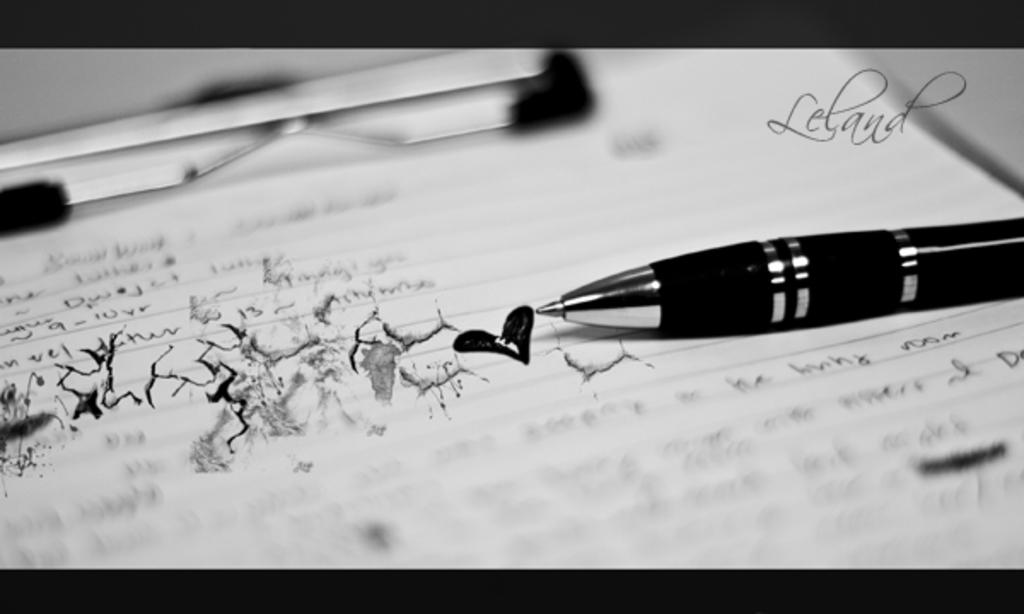What is on the pad in the image? There is a paper on a pad in the image. What is on the paper? There is a pen on the paper. What can be seen written on the paper? There is text written on the paper. What type of creature is holding the thread in the image? There is no creature or thread present in the image. 